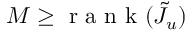Convert formula to latex. <formula><loc_0><loc_0><loc_500><loc_500>M \geq r a n k ( \tilde { J } _ { u } )</formula> 